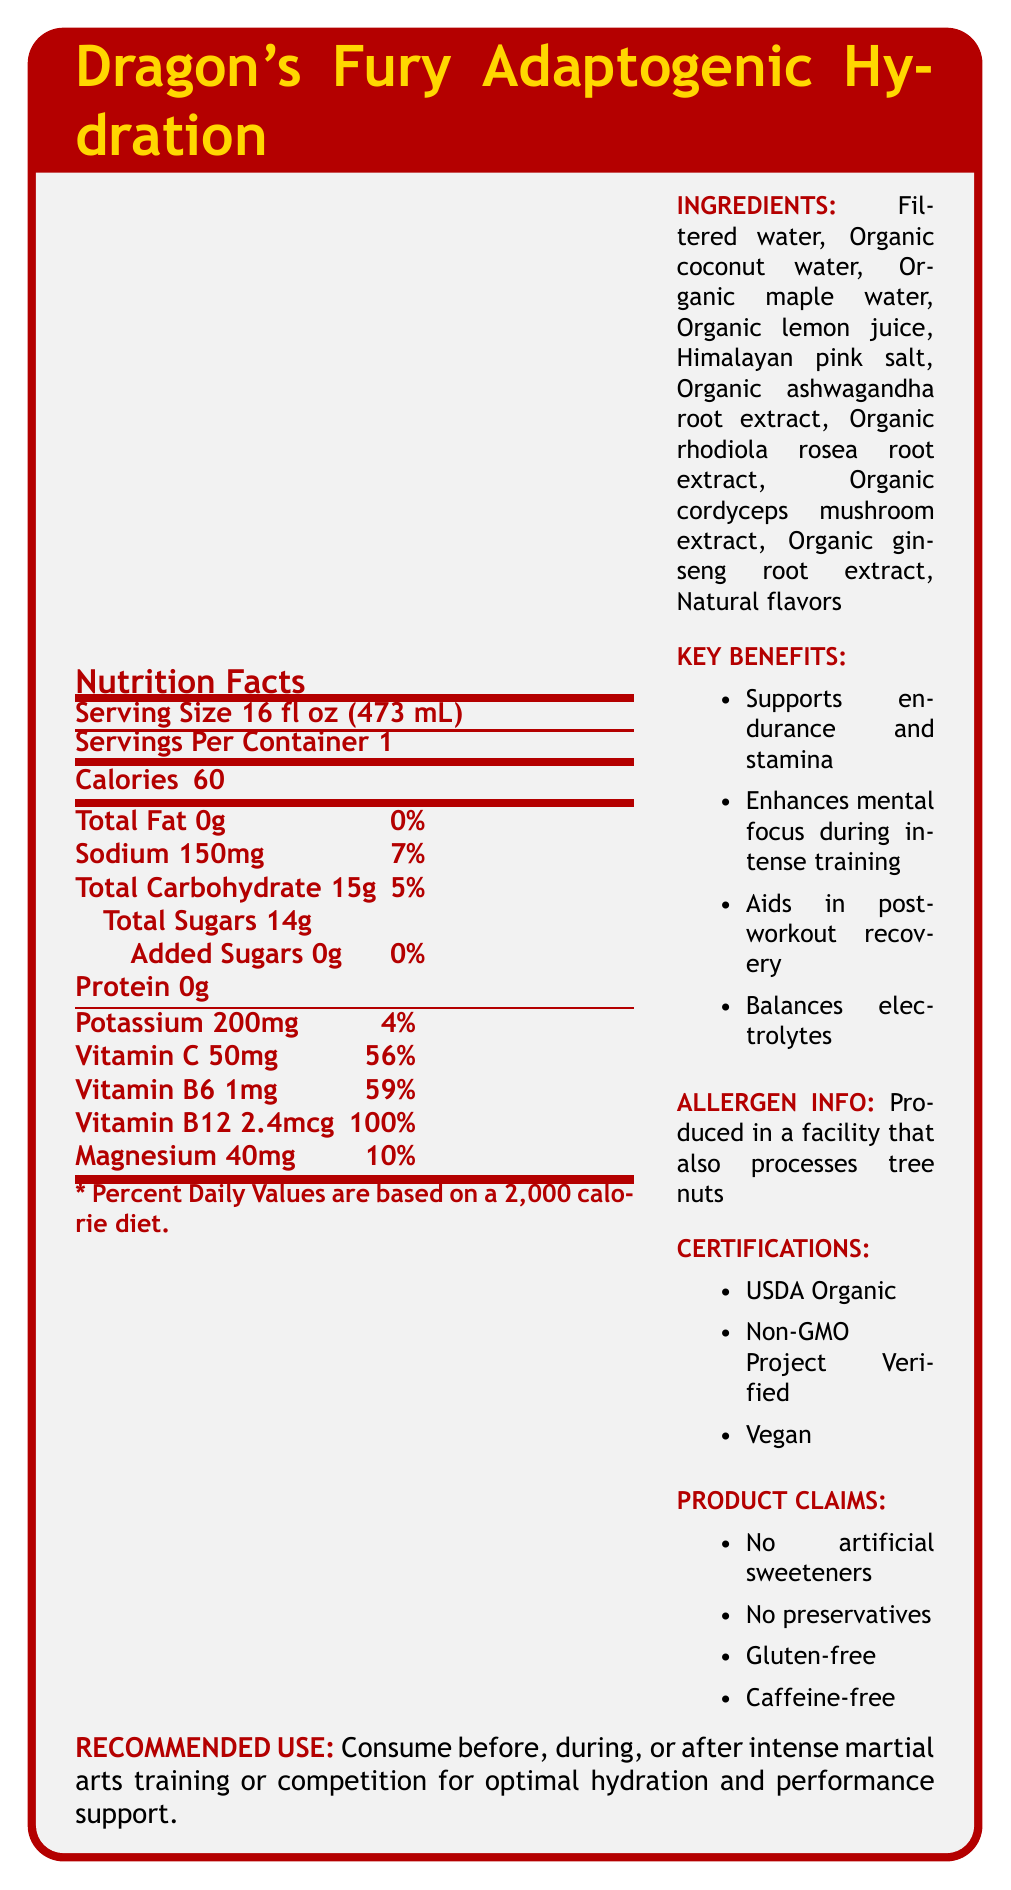what is the serving size for Dragon's Fury Adaptogenic Hydration? The document states that the serving size is 16 fl oz (473 mL).
Answer: 16 fl oz (473 mL) how many calories are there per serving? The Nutrition Facts section indicates that each serving contains 60 calories.
Answer: 60 calories what is the amount of sodium in this beverage? The document states that the sodium content is 150 mg per serving.
Answer: 150 mg what adaptogenic herbs are included in the ingredients? The ingredients list includes these adaptogenic herbs: Organic ashwagandha root extract, Organic rhodiola rosea root extract, Organic cordyceps mushroom extract, and Organic ginseng root extract.
Answer: Ashwagandha root extract, Rhodiola rosea root extract, Cordyceps mushroom extract, Ginseng root extract is this product suitable for vegans? The document states that the product is certified Vegan.
Answer: Yes what are the key benefits of this hydration beverage? The document lists these key benefits.
Answer: Supports endurance and stamina, Enhances mental focus during intense training, Aids in post-workout recovery, Balances electrolytes how much Vitamin C is in each serving? The Nutrition Facts section shows that each serving contains 50 mg of Vitamin C.
Answer: 50 mg how many grams of total carbohydrates are in this drink? According to the Nutrition Facts, the total carbohydrate content is 15 g.
Answer: 15 g what percentage of the daily value of Vitamin B12 is provided in one serving? The document states that one serving provides 100% of the daily value for Vitamin B12.
Answer: 100% which of the following is not listed as a product claim? A. No preservatives B. Gluten-free C. Sugar-free D. Caffeine-free The document lists no preservatives, gluten-free, and caffeine-free, but not sugar-free.
Answer: C. Sugar-free which certification does this product have? I. USDA Organic II. Fair Trade Certified III. Non-GMO Project Verified IV. Vegan The document states that the product is USDA Organic, Non-GMO Project Verified, and Vegan, but it does not mention Fair Trade Certified.
Answer: I, III, IV is the beverage recommended for use during training? The recommended use section suggests consuming the beverage before, during, or after intense martial arts training.
Answer: Yes summarize the main idea of the document The document provides detailed nutritional information, ingredients, benefits, and certifications of the beverage, highlighting its suitability for martial artists.
Answer: Dragon's Fury Adaptogenic Hydration is a natural sports hydration beverage designed for martial arts enthusiasts. It features adaptogenic herbs, supports endurance and recovery, and is certified organic, non-GMO, and vegan. The beverage contains key vitamins and minerals, has no artificial sweeteners or preservatives, and is suitable for intense training sessions. what is the price of Dragon's Fury Adaptogenic Hydration? The document does not provide any information regarding the price of the beverage.
Answer: Cannot be determined 